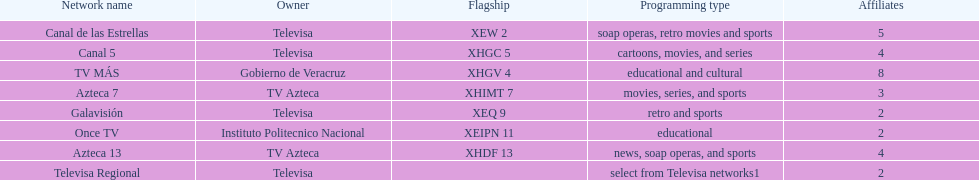Inform me the quantity of stations tv azteca possesses. 2. 